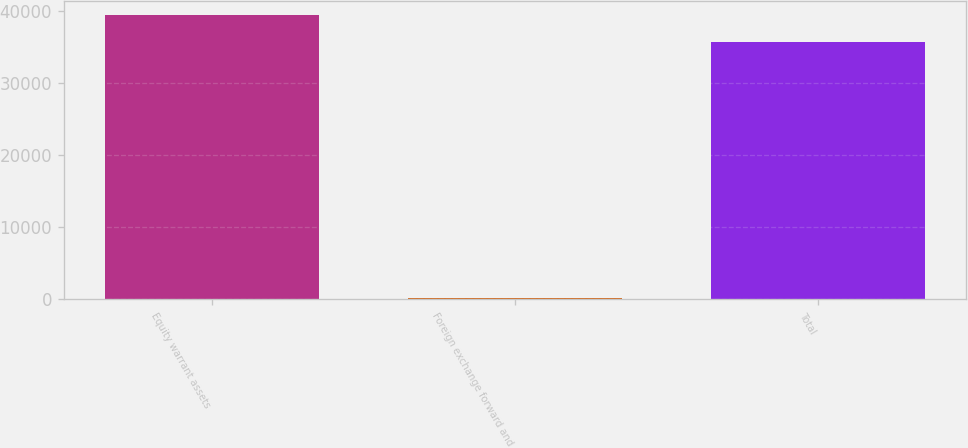<chart> <loc_0><loc_0><loc_500><loc_500><bar_chart><fcel>Equity warrant assets<fcel>Foreign exchange forward and<fcel>Total<nl><fcel>39427.1<fcel>164<fcel>35671<nl></chart> 